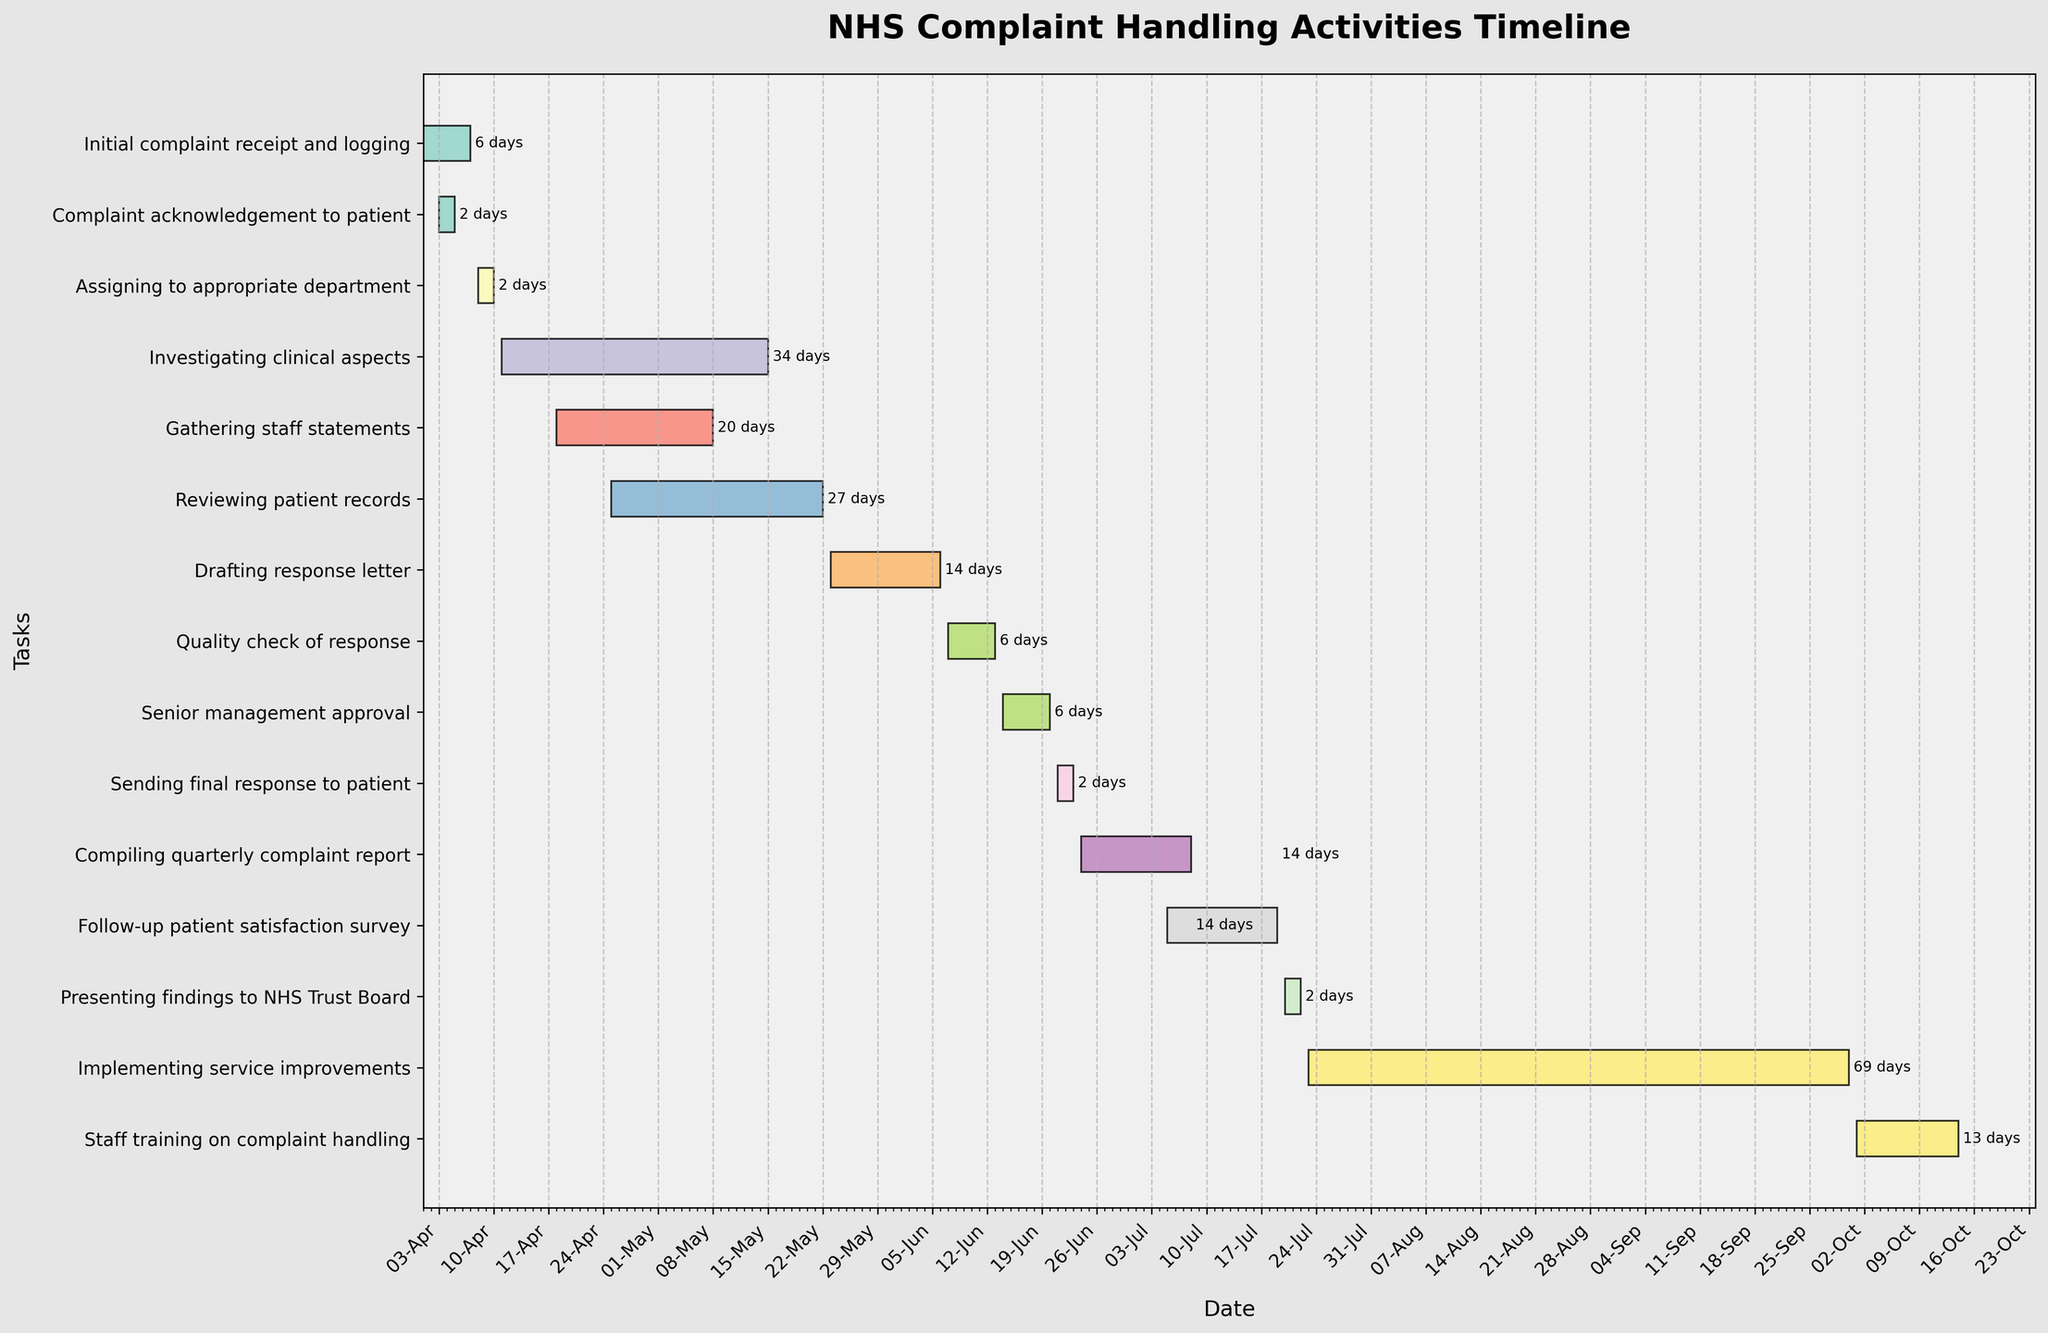What is the title of the Gantt Chart? The title of the Gantt Chart is clearly displayed at the top of the figure. It reads 'NHS Complaint Handling Activities Timeline'.
Answer: NHS Complaint Handling Activities Timeline How long did it take to investigate clinical aspects? To find out how long it took to investigate clinical aspects, look at the bar labeled 'Investigating clinical aspects' and read the duration mentioned at the end of the bar. It shows the process took 34 days.
Answer: 34 days Which task started first and which task ended last? The bars at the top and bottom of the Gantt Chart represent the tasks with the earliest start date and latest end date respectively. 'Initial complaint receipt and logging' started first on April 1, 2023, and 'Implementing service improvements’ ended last on September 30, 2023.
Answer: Initial complaint receipt and logging (started first), Implementing service improvements (ended last) Arrange the tasks in order of their start dates. You can arrange the tasks by looking at the start dates listed on the horizontal axis and matching them to the tasks on the vertical axis. The order from earliest to latest start dates is: Initial complaint receipt and logging, Complaint acknowledgement to patient, Assigning to appropriate department, Investigating clinical aspects, Gathering staff statements, Reviewing patient records, Drafting response letter, Quality check of response, Senior management approval, Sending final response to patient, Compiling quarterly complaint report, Follow-up patient satisfaction survey, Presenting findings to NHS Trust Board, Implementing service improvements, Staff training on complaint handling.
Answer: (Listed in order of their start dates) Which task overlaps with "Investigating clinical aspects"? To determine which tasks overlap with 'Investigating clinical aspects', locate tasks that have bars starting or ending within the range of April 11, 2023, to May 15, 2023. The tasks that overlap include 'Gathering staff statements' (April 18 to May 8), 'Reviewing patient records' (April 25 to May 22).
Answer: Gathering staff statements, Reviewing patient records How many days did it take to go from acknowledging receipt of a complaint to sending the final response to the patient? First, identify when the 'Complaint acknowledgement to patient' task started (April 3) and when the 'Sending final response to patient' task ended (June 23). Calculate the total number of days between these two tasks. From April 3 to June 23 is 81 days.
Answer: 81 days What is the duration for the 'Staff training on complaint handling' compared to 'Follow-up patient satisfaction survey'? Find the durations of both tasks by looking at the length of their respective bars. 'Staff training on complaint handling' lasts from October 1 to October 14, which is 14 days. 'Follow-up patient satisfaction survey' lasts from July 5 to July 19, which is 15 days. Compare the two durations; the training period is one day less than the survey period.
Answer: Staff training on complaint handling (14 days), Follow-up patient satisfaction survey (15 days) Does the 'Drafting response letter' task overlap with 'Quality check of response'? Identify the time frames for both tasks. 'Drafting response letter' occurs from May 23 to June 6, and 'Quality check of response' occurs from June 7 to June 13. Since the quality check starts the day after the drafting response letter ends, there is no overlap.
Answer: No What is the average duration of all tasks? To calculate the average duration, sum the durations of all tasks and divide by the total number of tasks. The durations are: 7, 3, 3, 34, 21, 27, 15, 7, 7, 3, 15, 15, 3, 70, 14 days. The total is 244 days, and with 15 tasks, the average duration is 244/15 = 16.27 days.
Answer: 16.27 days 